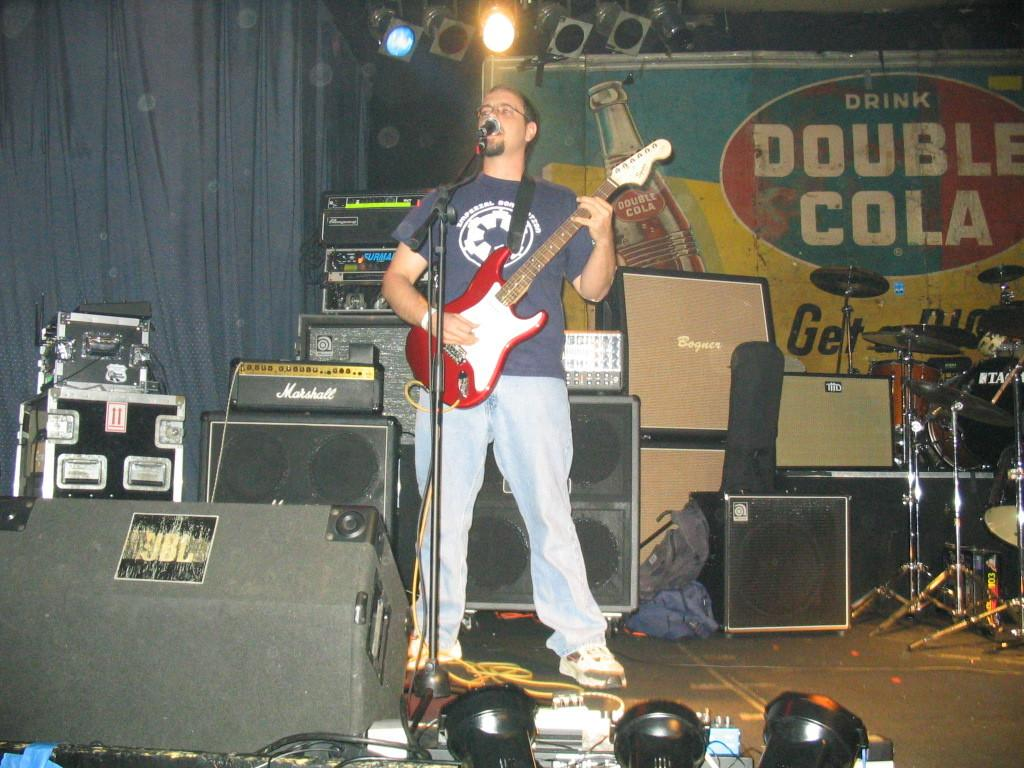What is the man in the center of the image doing? The man is standing in the center of the image and holding a guitar. What object is in front of the man? There is a microphone in front of the man. What other musical instruments can be seen around the man? There are musical instruments visible around the man. Can you describe the lighting in the image? There is light in the image. What additional objects are present in the image? There is a sheet and a banner in the image. How much profit is the man making in the image? There is no information about profit in the image. The image focuses on the man holding a guitar and the surrounding objects. 